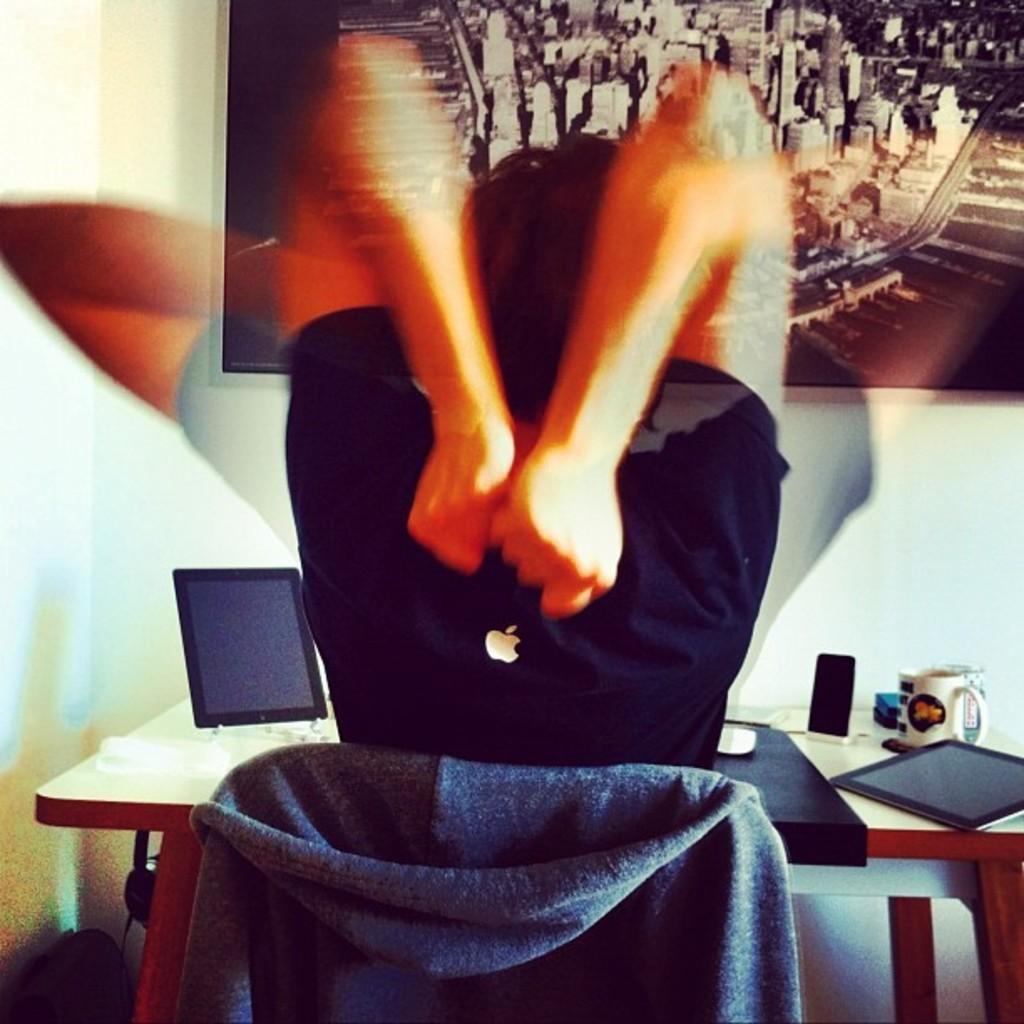Can you describe this image briefly? In this image we can see a persons sitting on the chair is waving his hands. We can see logo on his T-shirt. In the background, we can see a table where cups, mobile phone and few more things kept. Here we can see a photo frame on the wall. 